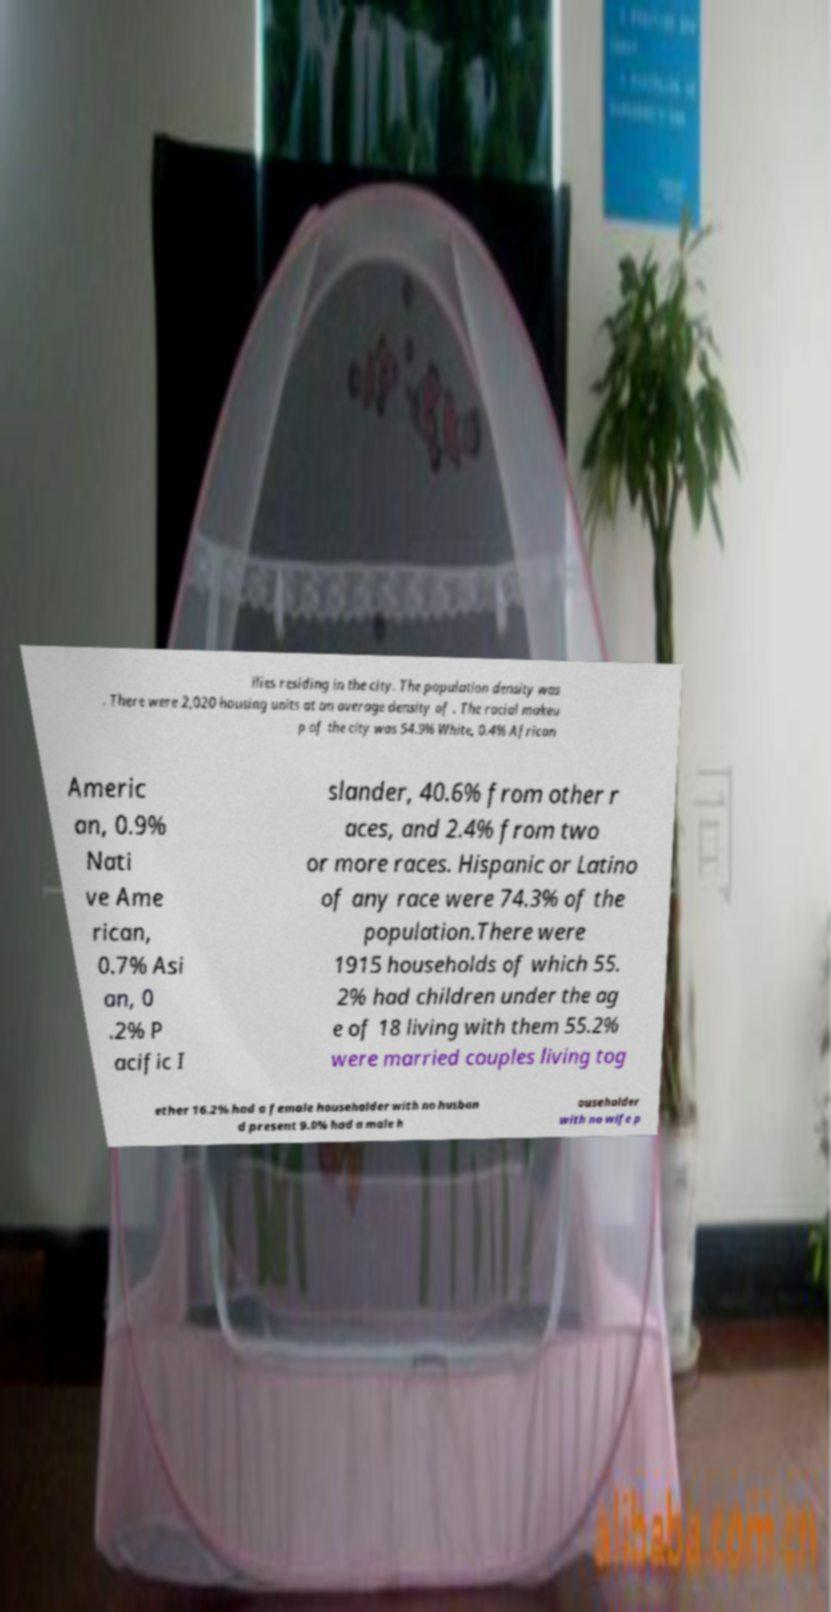Can you read and provide the text displayed in the image?This photo seems to have some interesting text. Can you extract and type it out for me? ilies residing in the city. The population density was . There were 2,020 housing units at an average density of . The racial makeu p of the city was 54.9% White, 0.4% African Americ an, 0.9% Nati ve Ame rican, 0.7% Asi an, 0 .2% P acific I slander, 40.6% from other r aces, and 2.4% from two or more races. Hispanic or Latino of any race were 74.3% of the population.There were 1915 households of which 55. 2% had children under the ag e of 18 living with them 55.2% were married couples living tog ether 16.2% had a female householder with no husban d present 9.0% had a male h ouseholder with no wife p 